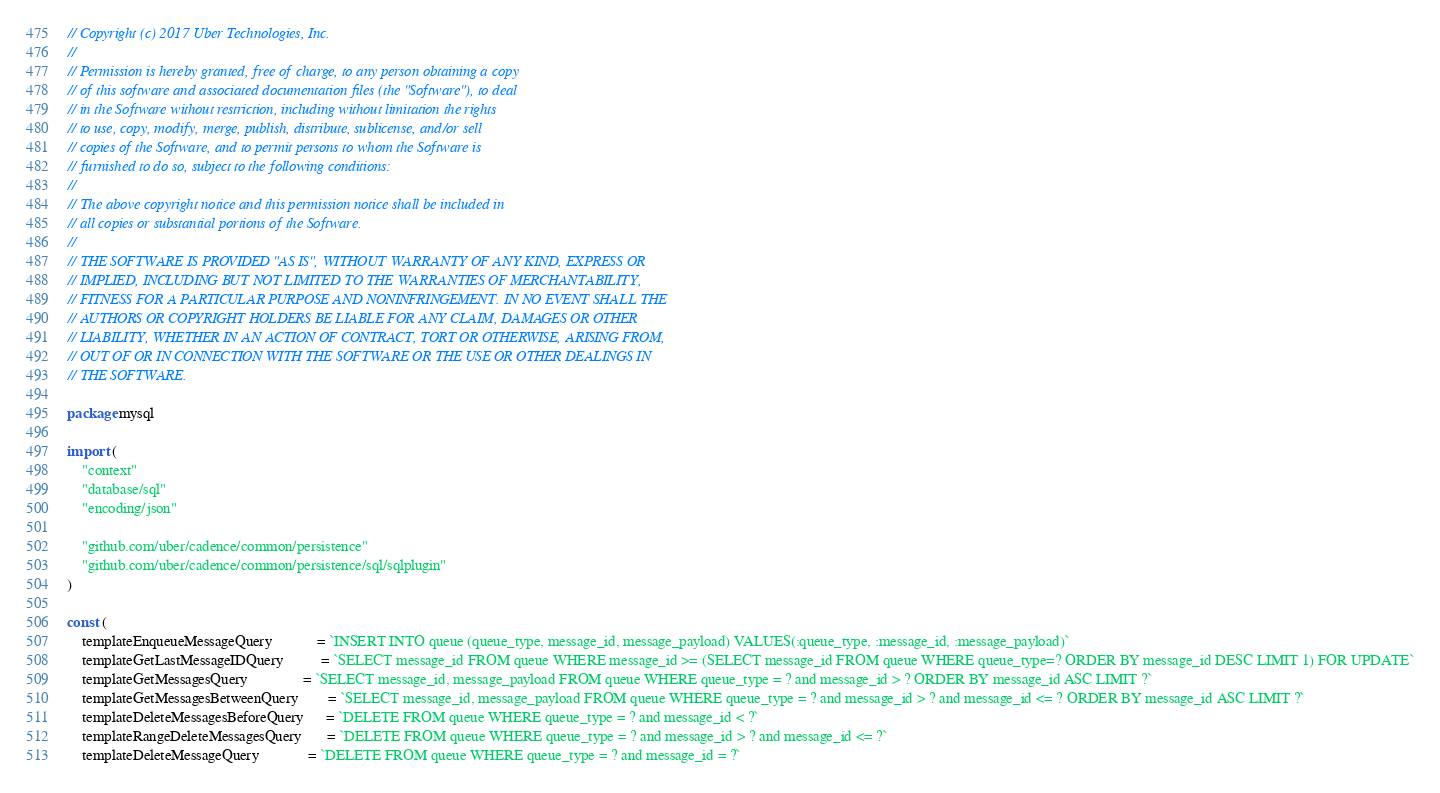<code> <loc_0><loc_0><loc_500><loc_500><_Go_>// Copyright (c) 2017 Uber Technologies, Inc.
//
// Permission is hereby granted, free of charge, to any person obtaining a copy
// of this software and associated documentation files (the "Software"), to deal
// in the Software without restriction, including without limitation the rights
// to use, copy, modify, merge, publish, distribute, sublicense, and/or sell
// copies of the Software, and to permit persons to whom the Software is
// furnished to do so, subject to the following conditions:
//
// The above copyright notice and this permission notice shall be included in
// all copies or substantial portions of the Software.
//
// THE SOFTWARE IS PROVIDED "AS IS", WITHOUT WARRANTY OF ANY KIND, EXPRESS OR
// IMPLIED, INCLUDING BUT NOT LIMITED TO THE WARRANTIES OF MERCHANTABILITY,
// FITNESS FOR A PARTICULAR PURPOSE AND NONINFRINGEMENT. IN NO EVENT SHALL THE
// AUTHORS OR COPYRIGHT HOLDERS BE LIABLE FOR ANY CLAIM, DAMAGES OR OTHER
// LIABILITY, WHETHER IN AN ACTION OF CONTRACT, TORT OR OTHERWISE, ARISING FROM,
// OUT OF OR IN CONNECTION WITH THE SOFTWARE OR THE USE OR OTHER DEALINGS IN
// THE SOFTWARE.

package mysql

import (
	"context"
	"database/sql"
	"encoding/json"

	"github.com/uber/cadence/common/persistence"
	"github.com/uber/cadence/common/persistence/sql/sqlplugin"
)

const (
	templateEnqueueMessageQuery            = `INSERT INTO queue (queue_type, message_id, message_payload) VALUES(:queue_type, :message_id, :message_payload)`
	templateGetLastMessageIDQuery          = `SELECT message_id FROM queue WHERE message_id >= (SELECT message_id FROM queue WHERE queue_type=? ORDER BY message_id DESC LIMIT 1) FOR UPDATE`
	templateGetMessagesQuery               = `SELECT message_id, message_payload FROM queue WHERE queue_type = ? and message_id > ? ORDER BY message_id ASC LIMIT ?`
	templateGetMessagesBetweenQuery        = `SELECT message_id, message_payload FROM queue WHERE queue_type = ? and message_id > ? and message_id <= ? ORDER BY message_id ASC LIMIT ?`
	templateDeleteMessagesBeforeQuery      = `DELETE FROM queue WHERE queue_type = ? and message_id < ?`
	templateRangeDeleteMessagesQuery       = `DELETE FROM queue WHERE queue_type = ? and message_id > ? and message_id <= ?`
	templateDeleteMessageQuery             = `DELETE FROM queue WHERE queue_type = ? and message_id = ?`</code> 